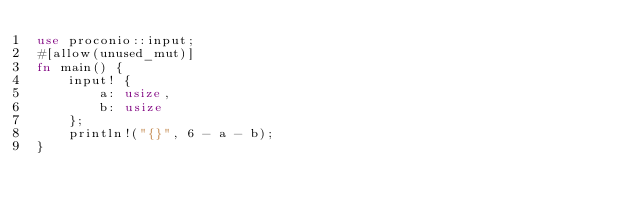<code> <loc_0><loc_0><loc_500><loc_500><_Rust_>use proconio::input;
#[allow(unused_mut)]
fn main() {
    input! {
        a: usize,
        b: usize
    };
    println!("{}", 6 - a - b);
}
</code> 